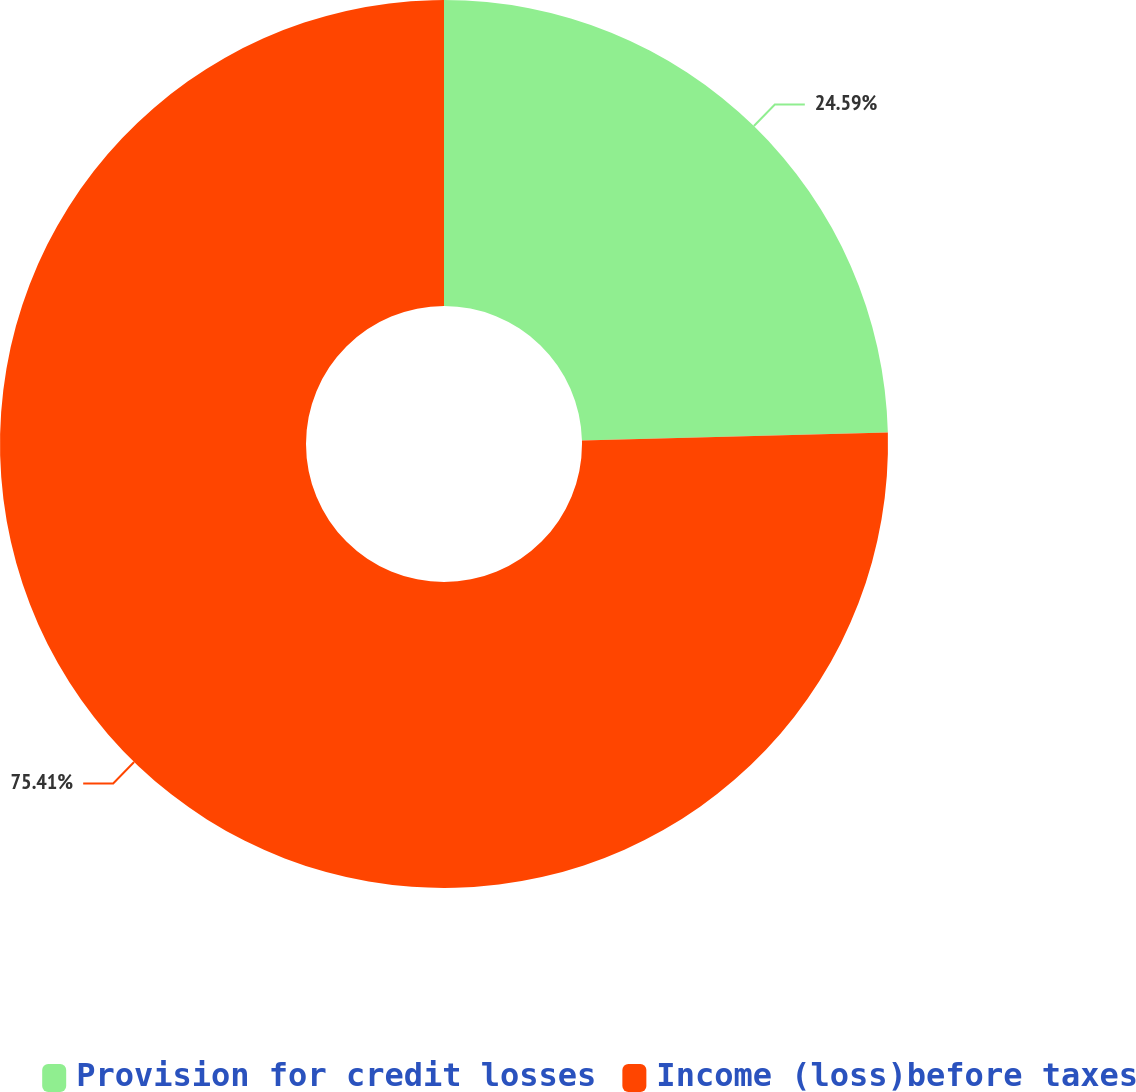Convert chart to OTSL. <chart><loc_0><loc_0><loc_500><loc_500><pie_chart><fcel>Provision for credit losses<fcel>Income (loss)before taxes<nl><fcel>24.59%<fcel>75.41%<nl></chart> 